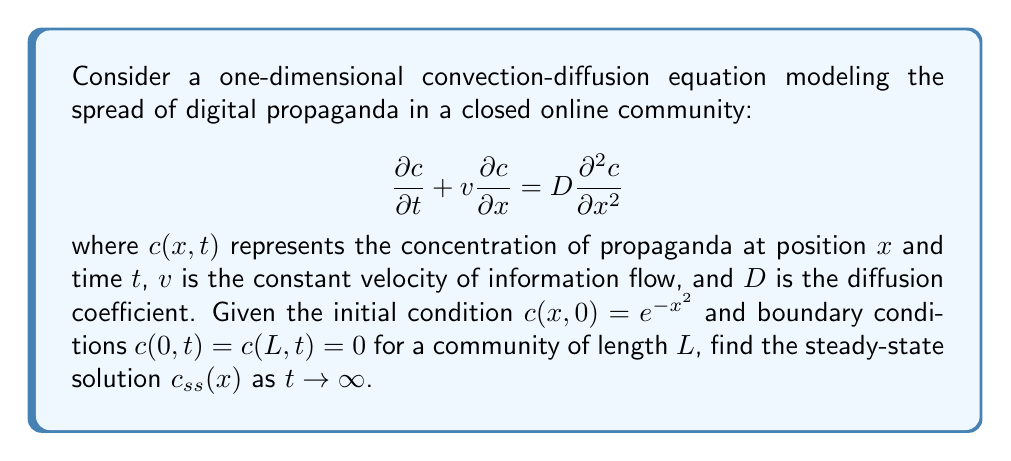Could you help me with this problem? To find the steady-state solution, we follow these steps:

1) In steady-state, the concentration doesn't change with time, so $\frac{\partial c}{\partial t} = 0$. The equation becomes:

   $$v\frac{dc_{ss}}{dx} = D\frac{d^2c_{ss}}{dx^2}$$

2) This is a second-order ODE. We can solve it by first dividing both sides by $D$:

   $$\frac{v}{D}\frac{dc_{ss}}{dx} = \frac{d^2c_{ss}}{dx^2}$$

3) Let $u = \frac{dc_{ss}}{dx}$. Then the equation becomes:

   $$\frac{v}{D}u = \frac{du}{dx}$$

4) This is a separable first-order ODE. Solving it:

   $$\int \frac{du}{u} = \int \frac{v}{D}dx$$
   $$\ln|u| = \frac{v}{D}x + C_1$$
   $$u = C_2e^{\frac{v}{D}x}$$

5) Substituting back $u = \frac{dc_{ss}}{dx}$:

   $$\frac{dc_{ss}}{dx} = C_2e^{\frac{v}{D}x}$$

6) Integrating again:

   $$c_{ss} = \frac{C_2D}{v}e^{\frac{v}{D}x} + C_3$$

7) Now we apply the boundary conditions:
   At $x = 0$: $c_{ss}(0) = \frac{C_2D}{v} + C_3 = 0$
   At $x = L$: $c_{ss}(L) = \frac{C_2D}{v}e^{\frac{vL}{D}} + C_3 = 0$

8) Subtracting these equations:

   $$\frac{C_2D}{v}(e^{\frac{vL}{D}} - 1) = 0$$

   This is only true if $C_2 = 0$ (since $e^{\frac{vL}{D}} \neq 1$ for non-zero $v$, $D$, and $L$).

9) Therefore, $C_3 = 0$ as well.

Thus, the only solution satisfying the boundary conditions is the trivial solution.
Answer: The steady-state solution is $c_{ss}(x) = 0$ for all $x \in [0,L]$. 